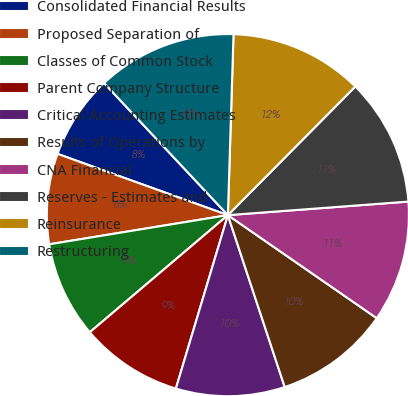Convert chart. <chart><loc_0><loc_0><loc_500><loc_500><pie_chart><fcel>Consolidated Financial Results<fcel>Proposed Separation of<fcel>Classes of Common Stock<fcel>Parent Company Structure<fcel>Critical Accounting Estimates<fcel>Results of Operations by<fcel>CNA Financial<fcel>Reserves - Estimates and<fcel>Reinsurance<fcel>Restructuring<nl><fcel>7.52%<fcel>8.07%<fcel>8.62%<fcel>9.17%<fcel>9.72%<fcel>10.28%<fcel>10.83%<fcel>11.38%<fcel>11.93%<fcel>12.48%<nl></chart> 